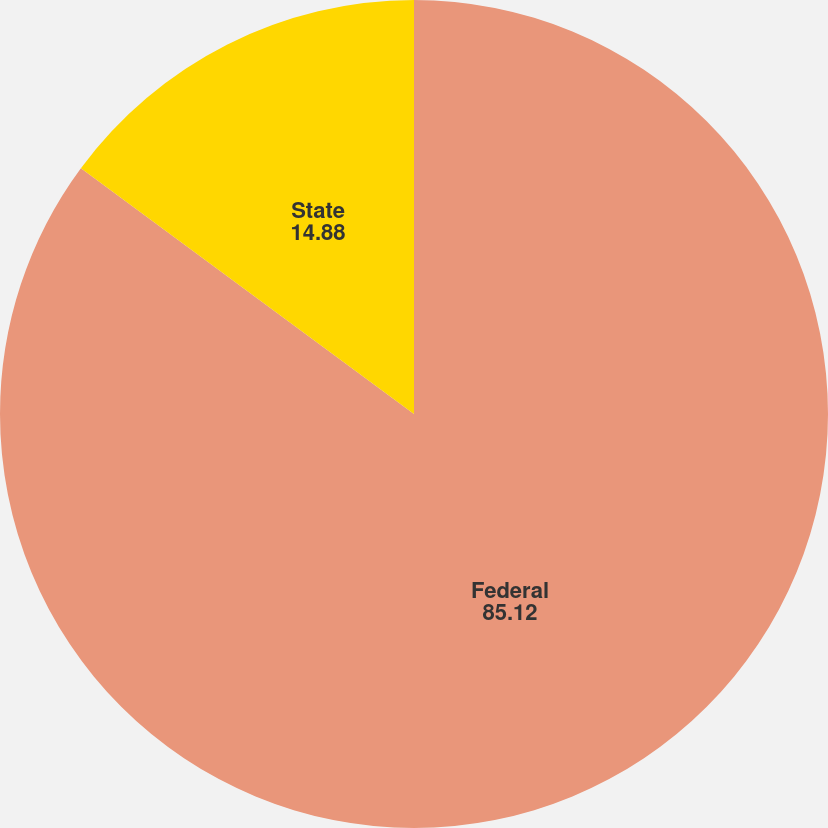Convert chart. <chart><loc_0><loc_0><loc_500><loc_500><pie_chart><fcel>Federal<fcel>State<nl><fcel>85.12%<fcel>14.88%<nl></chart> 